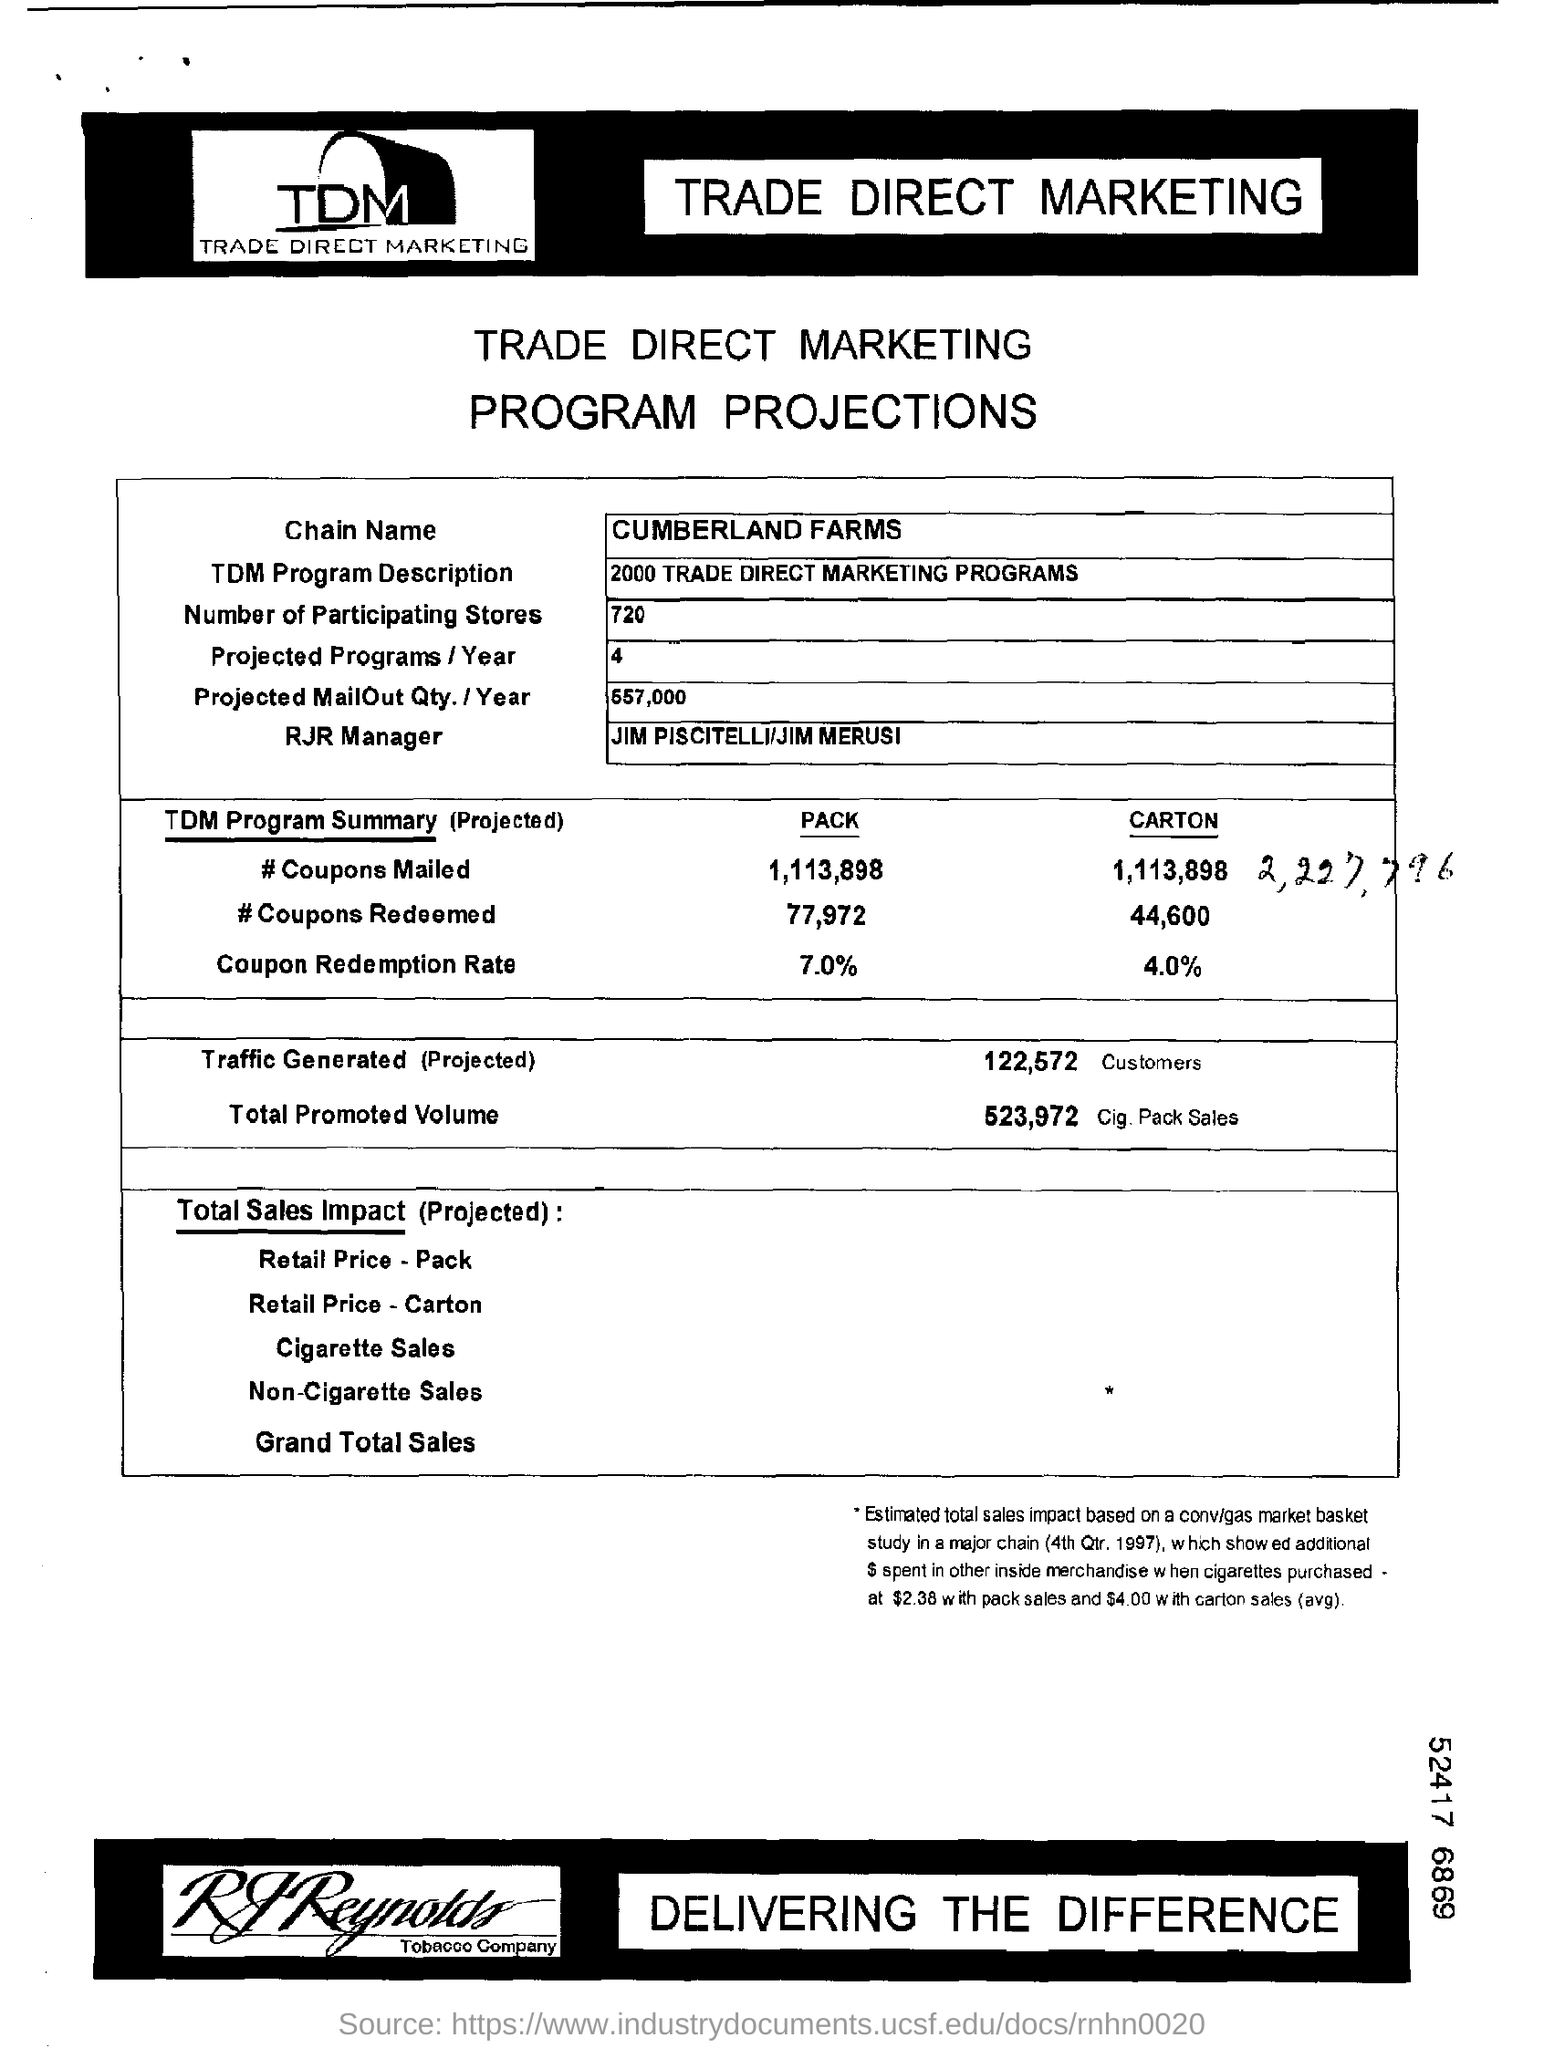Specify some key components in this picture. RJR has a manager named Jim Piscitelli and Jim Merusi. There are 720 participating stores. The TDM program is a description of 2000 trade direct marketing programs. 